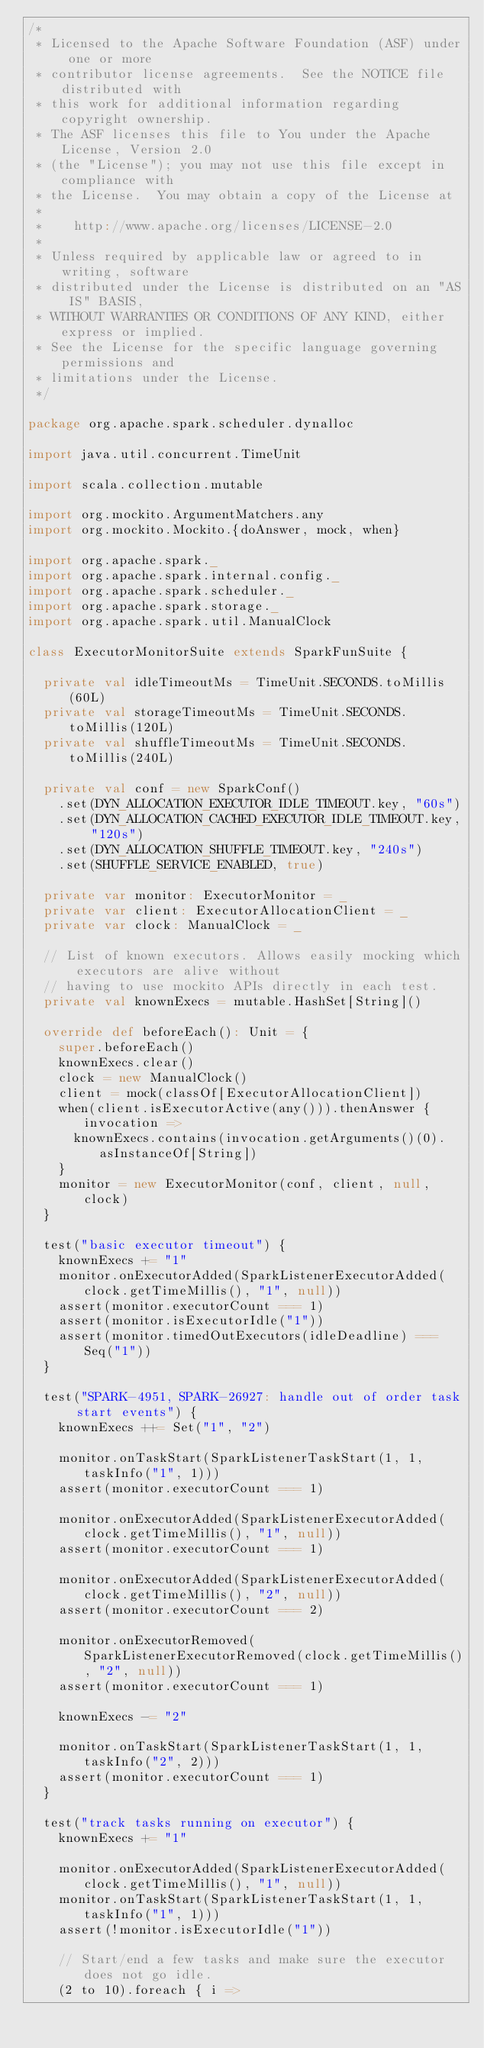<code> <loc_0><loc_0><loc_500><loc_500><_Scala_>/*
 * Licensed to the Apache Software Foundation (ASF) under one or more
 * contributor license agreements.  See the NOTICE file distributed with
 * this work for additional information regarding copyright ownership.
 * The ASF licenses this file to You under the Apache License, Version 2.0
 * (the "License"); you may not use this file except in compliance with
 * the License.  You may obtain a copy of the License at
 *
 *    http://www.apache.org/licenses/LICENSE-2.0
 *
 * Unless required by applicable law or agreed to in writing, software
 * distributed under the License is distributed on an "AS IS" BASIS,
 * WITHOUT WARRANTIES OR CONDITIONS OF ANY KIND, either express or implied.
 * See the License for the specific language governing permissions and
 * limitations under the License.
 */

package org.apache.spark.scheduler.dynalloc

import java.util.concurrent.TimeUnit

import scala.collection.mutable

import org.mockito.ArgumentMatchers.any
import org.mockito.Mockito.{doAnswer, mock, when}

import org.apache.spark._
import org.apache.spark.internal.config._
import org.apache.spark.scheduler._
import org.apache.spark.storage._
import org.apache.spark.util.ManualClock

class ExecutorMonitorSuite extends SparkFunSuite {

  private val idleTimeoutMs = TimeUnit.SECONDS.toMillis(60L)
  private val storageTimeoutMs = TimeUnit.SECONDS.toMillis(120L)
  private val shuffleTimeoutMs = TimeUnit.SECONDS.toMillis(240L)

  private val conf = new SparkConf()
    .set(DYN_ALLOCATION_EXECUTOR_IDLE_TIMEOUT.key, "60s")
    .set(DYN_ALLOCATION_CACHED_EXECUTOR_IDLE_TIMEOUT.key, "120s")
    .set(DYN_ALLOCATION_SHUFFLE_TIMEOUT.key, "240s")
    .set(SHUFFLE_SERVICE_ENABLED, true)

  private var monitor: ExecutorMonitor = _
  private var client: ExecutorAllocationClient = _
  private var clock: ManualClock = _

  // List of known executors. Allows easily mocking which executors are alive without
  // having to use mockito APIs directly in each test.
  private val knownExecs = mutable.HashSet[String]()

  override def beforeEach(): Unit = {
    super.beforeEach()
    knownExecs.clear()
    clock = new ManualClock()
    client = mock(classOf[ExecutorAllocationClient])
    when(client.isExecutorActive(any())).thenAnswer { invocation =>
      knownExecs.contains(invocation.getArguments()(0).asInstanceOf[String])
    }
    monitor = new ExecutorMonitor(conf, client, null, clock)
  }

  test("basic executor timeout") {
    knownExecs += "1"
    monitor.onExecutorAdded(SparkListenerExecutorAdded(clock.getTimeMillis(), "1", null))
    assert(monitor.executorCount === 1)
    assert(monitor.isExecutorIdle("1"))
    assert(monitor.timedOutExecutors(idleDeadline) === Seq("1"))
  }

  test("SPARK-4951, SPARK-26927: handle out of order task start events") {
    knownExecs ++= Set("1", "2")

    monitor.onTaskStart(SparkListenerTaskStart(1, 1, taskInfo("1", 1)))
    assert(monitor.executorCount === 1)

    monitor.onExecutorAdded(SparkListenerExecutorAdded(clock.getTimeMillis(), "1", null))
    assert(monitor.executorCount === 1)

    monitor.onExecutorAdded(SparkListenerExecutorAdded(clock.getTimeMillis(), "2", null))
    assert(monitor.executorCount === 2)

    monitor.onExecutorRemoved(SparkListenerExecutorRemoved(clock.getTimeMillis(), "2", null))
    assert(monitor.executorCount === 1)

    knownExecs -= "2"

    monitor.onTaskStart(SparkListenerTaskStart(1, 1, taskInfo("2", 2)))
    assert(monitor.executorCount === 1)
  }

  test("track tasks running on executor") {
    knownExecs += "1"

    monitor.onExecutorAdded(SparkListenerExecutorAdded(clock.getTimeMillis(), "1", null))
    monitor.onTaskStart(SparkListenerTaskStart(1, 1, taskInfo("1", 1)))
    assert(!monitor.isExecutorIdle("1"))

    // Start/end a few tasks and make sure the executor does not go idle.
    (2 to 10).foreach { i =></code> 